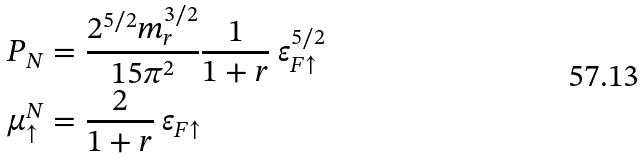Convert formula to latex. <formula><loc_0><loc_0><loc_500><loc_500>P _ { N } & = \frac { 2 ^ { 5 / 2 } m _ { r } ^ { 3 / 2 } } { 1 5 \pi ^ { 2 } } \frac { 1 } { 1 + r } \ \varepsilon _ { F \uparrow } ^ { 5 / 2 } \\ \mu ^ { N } _ { \uparrow } & = \frac { 2 } { 1 + r } \ \varepsilon _ { F \uparrow }</formula> 